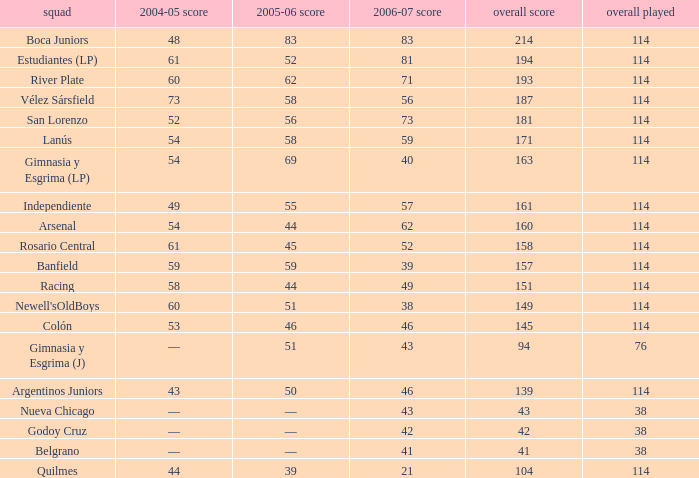What is the total pld with 158 points in 2006-07, and less than 52 points in 2006-07? None. 